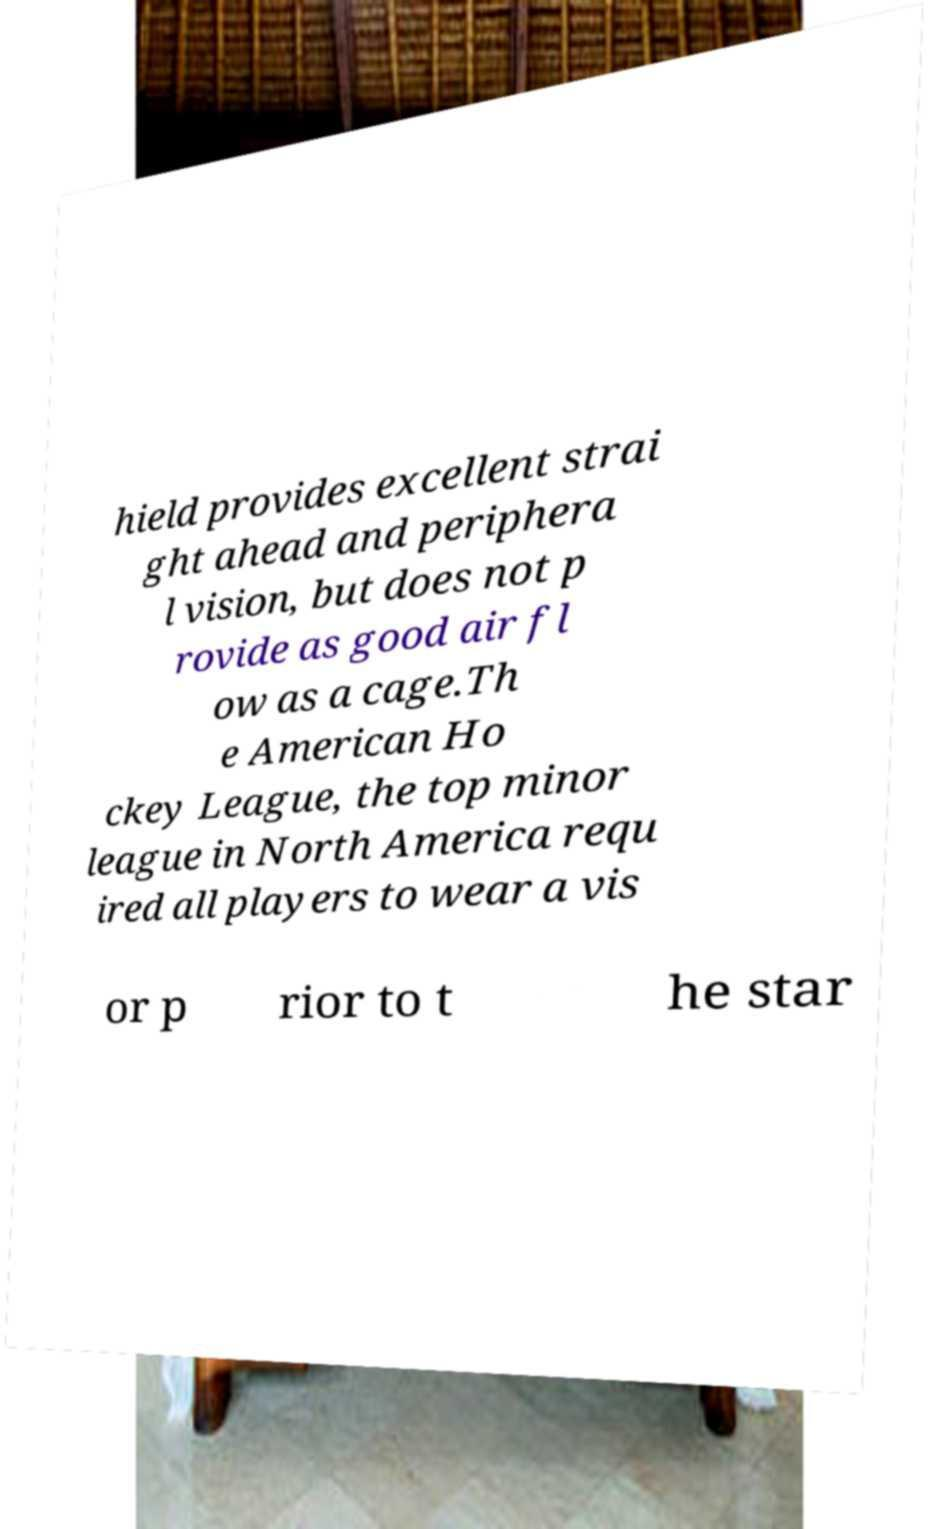For documentation purposes, I need the text within this image transcribed. Could you provide that? hield provides excellent strai ght ahead and periphera l vision, but does not p rovide as good air fl ow as a cage.Th e American Ho ckey League, the top minor league in North America requ ired all players to wear a vis or p rior to t he star 